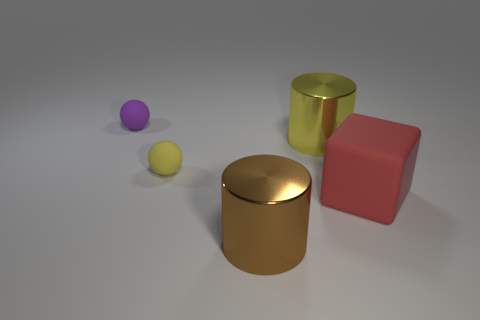Are there any gray objects of the same size as the red rubber cube?
Your response must be concise. No. Does the sphere that is right of the purple matte thing have the same size as the cylinder that is in front of the red rubber block?
Your answer should be very brief. No. There is a small rubber thing that is in front of the metal thing behind the brown metal object; what is its shape?
Your answer should be compact. Sphere. There is a red block; how many red matte cubes are on the right side of it?
Keep it short and to the point. 0. There is another tiny ball that is the same material as the tiny yellow sphere; what is its color?
Ensure brevity in your answer.  Purple. Is the size of the red block the same as the rubber sphere on the right side of the tiny purple rubber object?
Keep it short and to the point. No. There is a metallic object in front of the yellow rubber object on the left side of the cylinder that is in front of the yellow cylinder; how big is it?
Your answer should be compact. Large. What number of metal things are either large gray cylinders or cubes?
Your response must be concise. 0. There is a big shiny cylinder behind the big brown thing; what color is it?
Provide a short and direct response. Yellow. There is a purple matte object that is the same size as the yellow matte object; what is its shape?
Give a very brief answer. Sphere. 